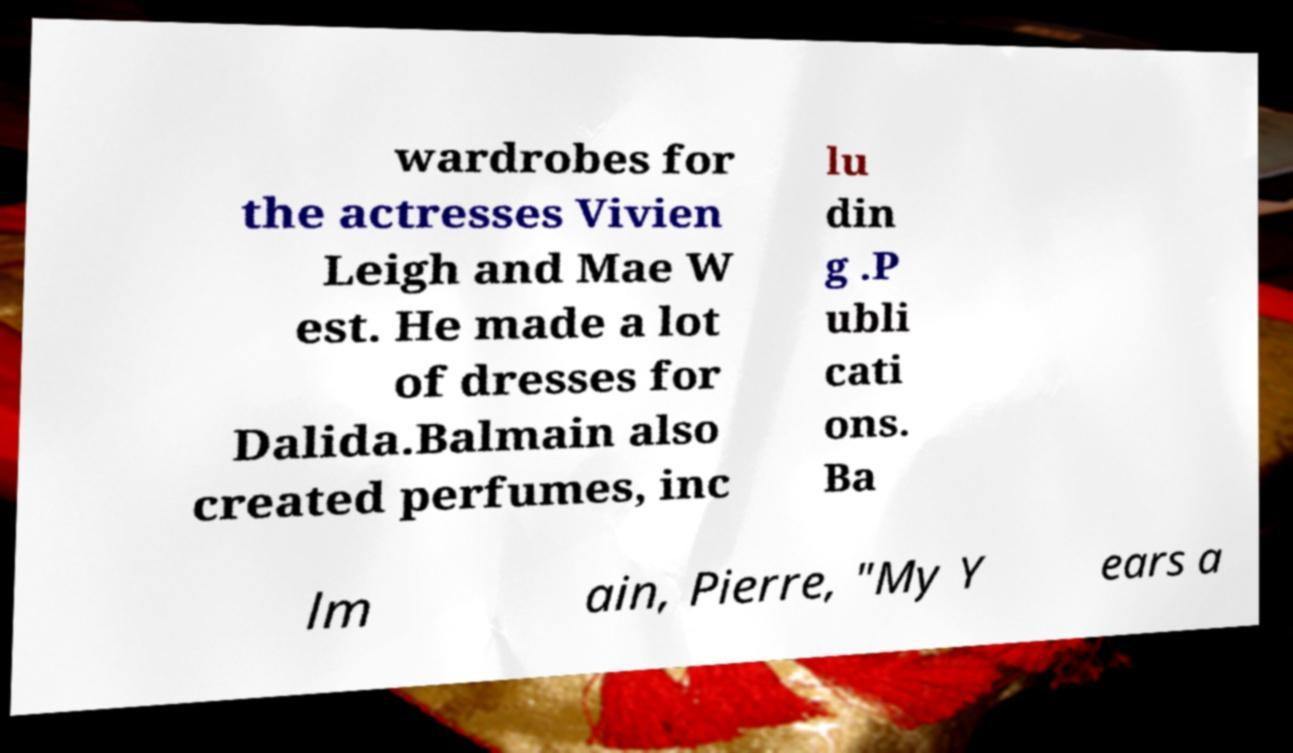For documentation purposes, I need the text within this image transcribed. Could you provide that? wardrobes for the actresses Vivien Leigh and Mae W est. He made a lot of dresses for Dalida.Balmain also created perfumes, inc lu din g .P ubli cati ons. Ba lm ain, Pierre, "My Y ears a 